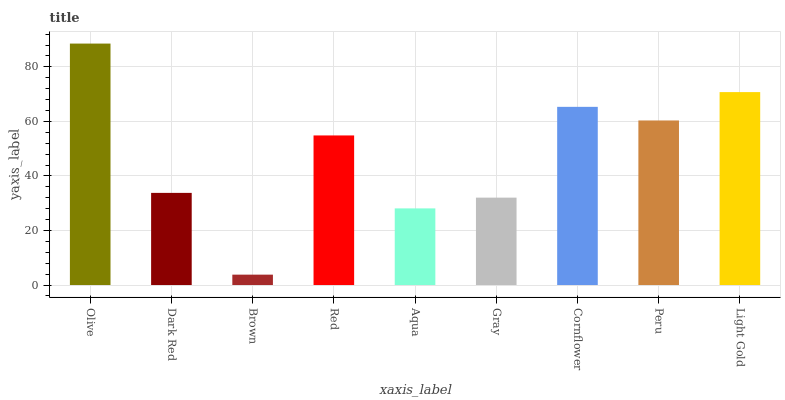Is Brown the minimum?
Answer yes or no. Yes. Is Olive the maximum?
Answer yes or no. Yes. Is Dark Red the minimum?
Answer yes or no. No. Is Dark Red the maximum?
Answer yes or no. No. Is Olive greater than Dark Red?
Answer yes or no. Yes. Is Dark Red less than Olive?
Answer yes or no. Yes. Is Dark Red greater than Olive?
Answer yes or no. No. Is Olive less than Dark Red?
Answer yes or no. No. Is Red the high median?
Answer yes or no. Yes. Is Red the low median?
Answer yes or no. Yes. Is Gray the high median?
Answer yes or no. No. Is Olive the low median?
Answer yes or no. No. 